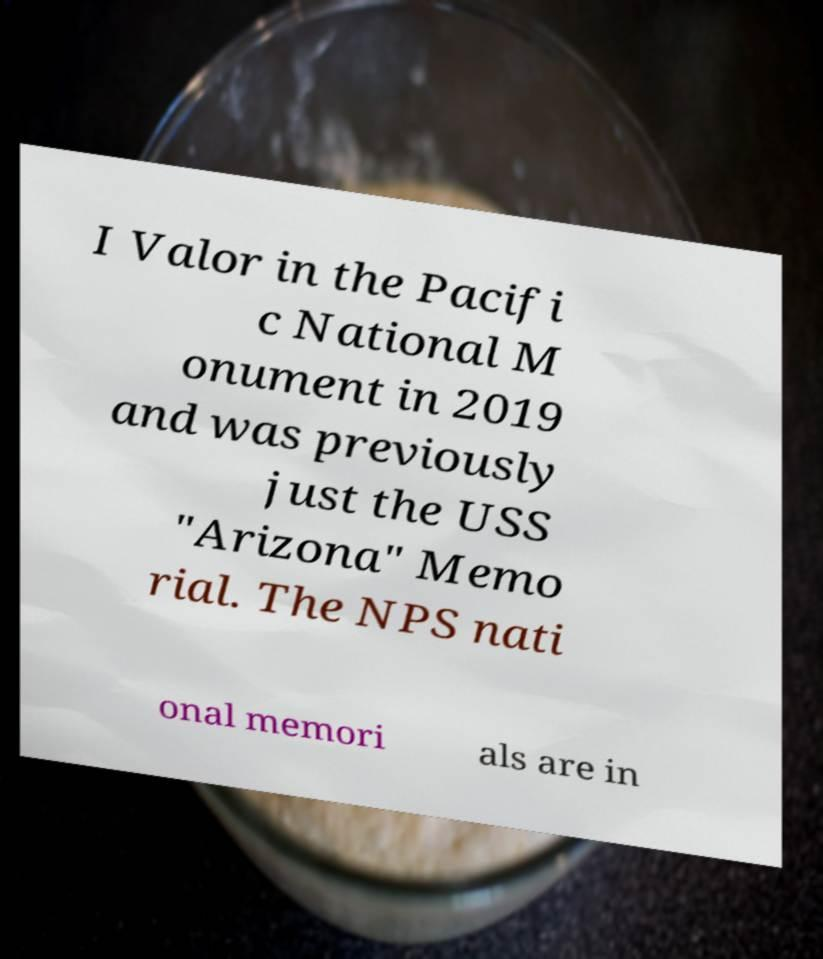For documentation purposes, I need the text within this image transcribed. Could you provide that? I Valor in the Pacifi c National M onument in 2019 and was previously just the USS "Arizona" Memo rial. The NPS nati onal memori als are in 